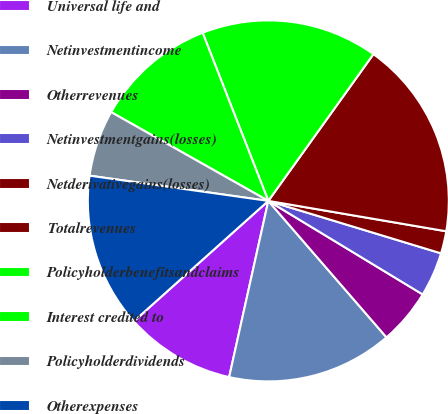Convert chart. <chart><loc_0><loc_0><loc_500><loc_500><pie_chart><fcel>Universal life and<fcel>Netinvestmentincome<fcel>Otherrevenues<fcel>Netinvestmentgains(losses)<fcel>Netderivativegains(losses)<fcel>Totalrevenues<fcel>Policyholderbenefitsandclaims<fcel>Interest credited to<fcel>Policyholderdividends<fcel>Otherexpenses<nl><fcel>9.9%<fcel>14.84%<fcel>4.97%<fcel>3.98%<fcel>2.0%<fcel>17.8%<fcel>15.82%<fcel>10.89%<fcel>5.95%<fcel>13.85%<nl></chart> 